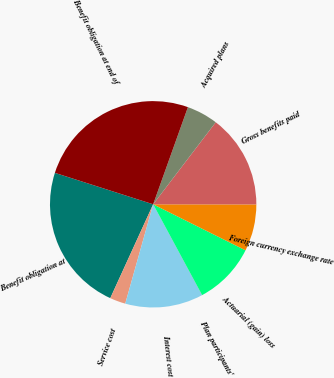<chart> <loc_0><loc_0><loc_500><loc_500><pie_chart><fcel>Benefit obligation at<fcel>Service cost<fcel>Interest cost<fcel>Plan participants'<fcel>Actuarial (gain) loss<fcel>Foreign currency exchange rate<fcel>Gross benefits paid<fcel>Acquired plans<fcel>Benefit obligation at end of<nl><fcel>23.11%<fcel>2.46%<fcel>12.21%<fcel>0.02%<fcel>9.77%<fcel>7.34%<fcel>14.65%<fcel>4.9%<fcel>25.54%<nl></chart> 